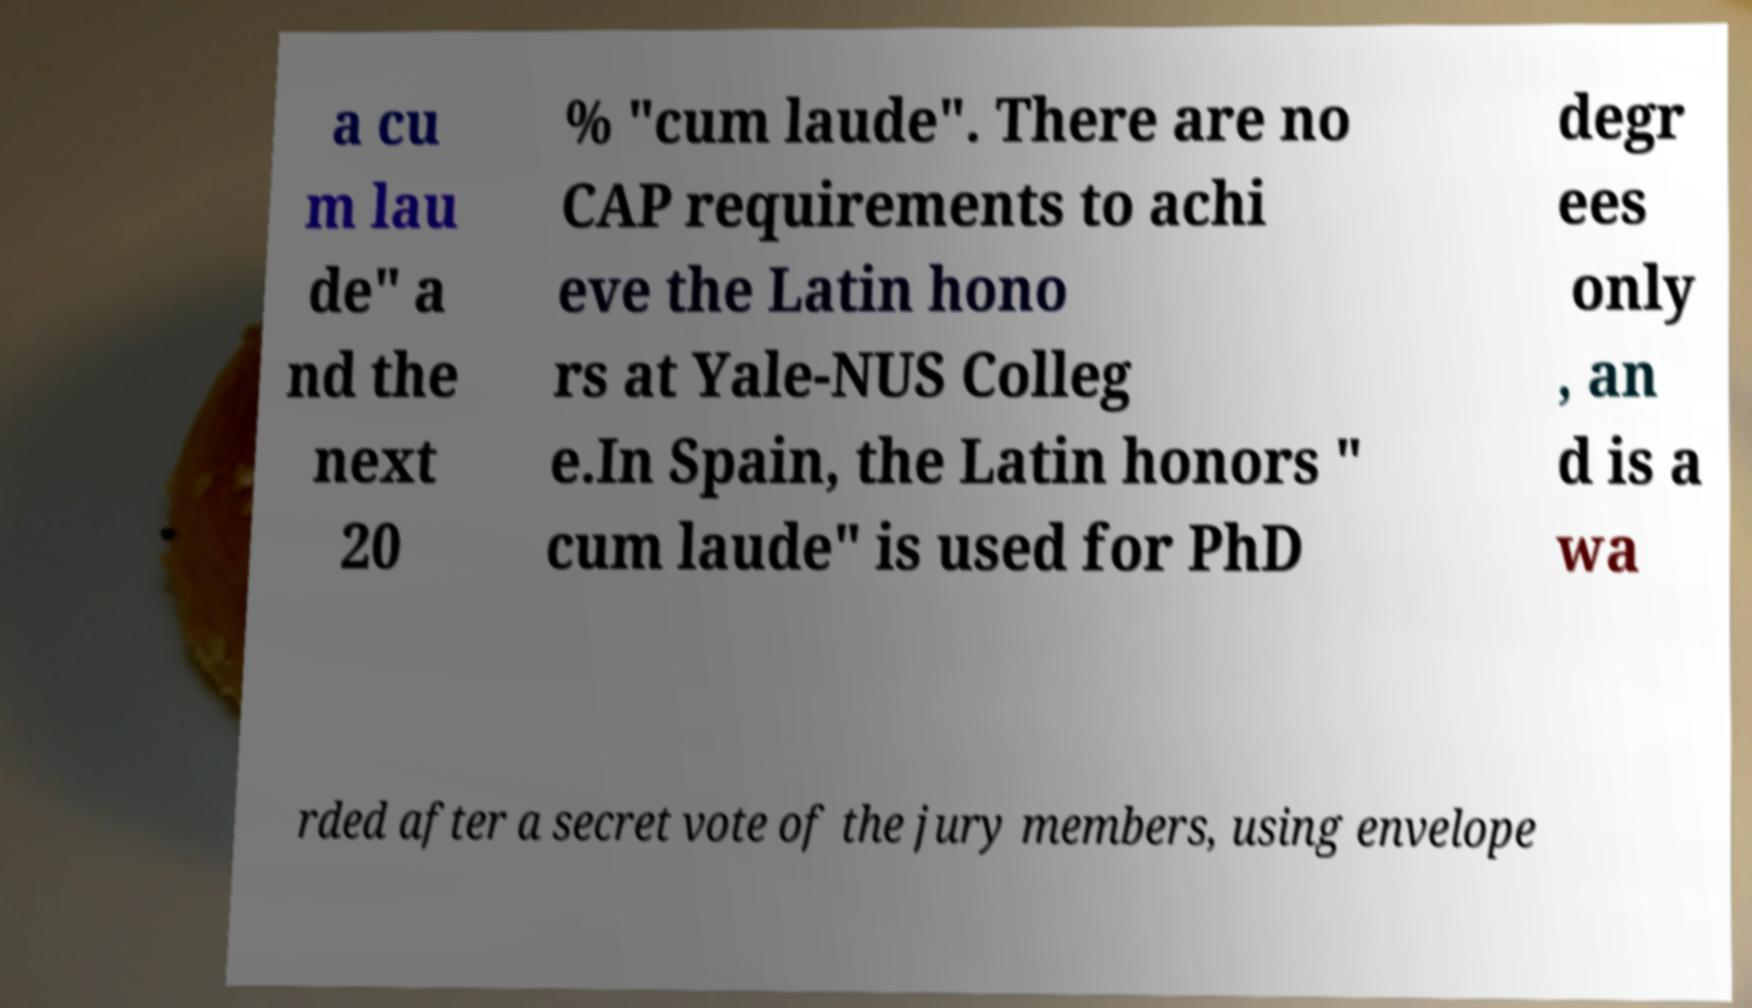Please identify and transcribe the text found in this image. a cu m lau de" a nd the next 20 % "cum laude". There are no CAP requirements to achi eve the Latin hono rs at Yale-NUS Colleg e.In Spain, the Latin honors " cum laude" is used for PhD degr ees only , an d is a wa rded after a secret vote of the jury members, using envelope 